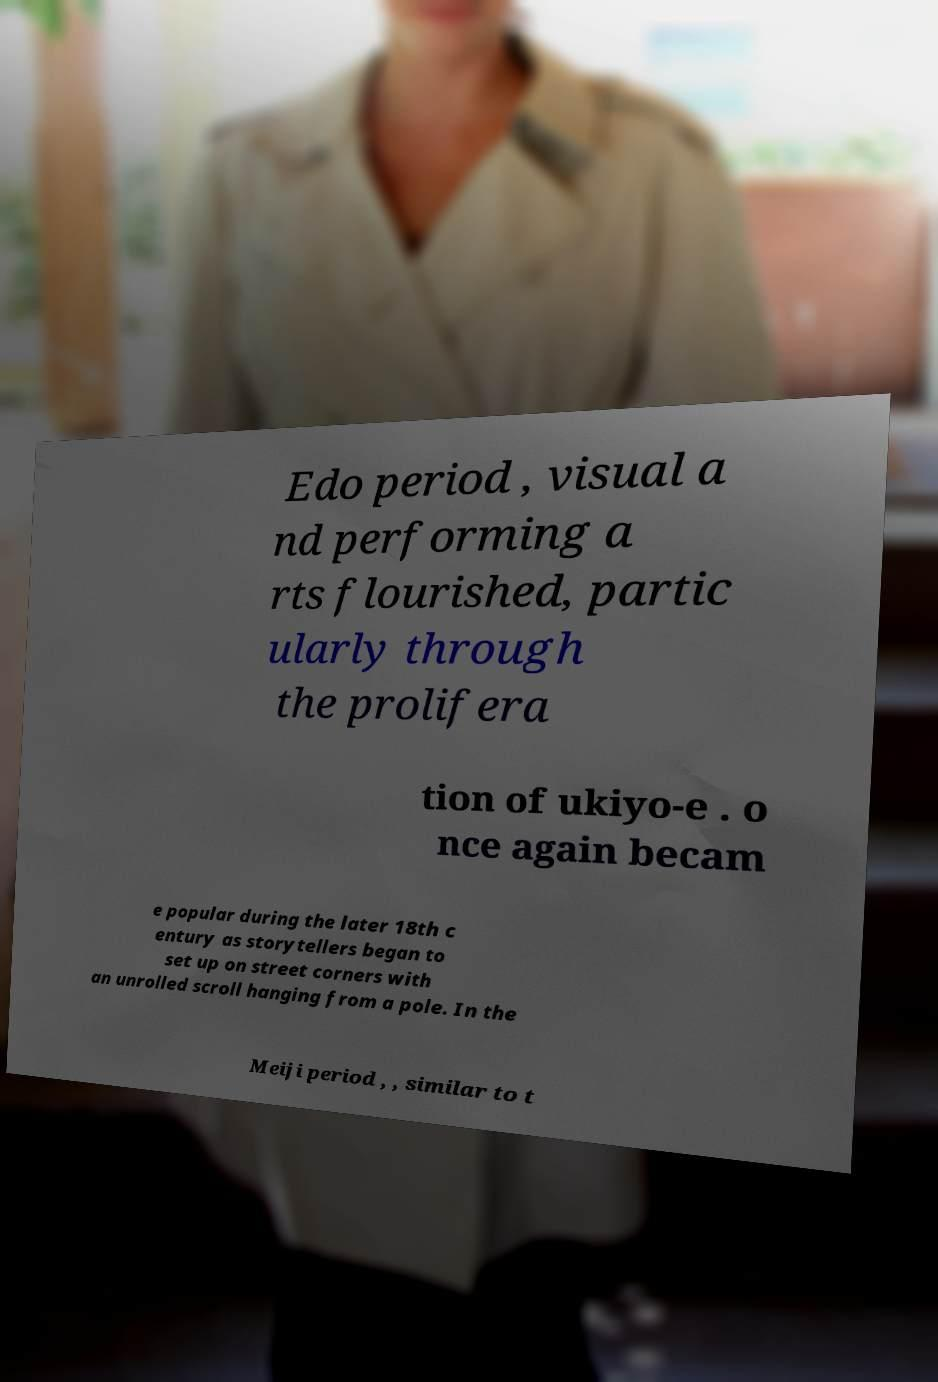Can you accurately transcribe the text from the provided image for me? Edo period , visual a nd performing a rts flourished, partic ularly through the prolifera tion of ukiyo-e . o nce again becam e popular during the later 18th c entury as storytellers began to set up on street corners with an unrolled scroll hanging from a pole. In the Meiji period , , similar to t 